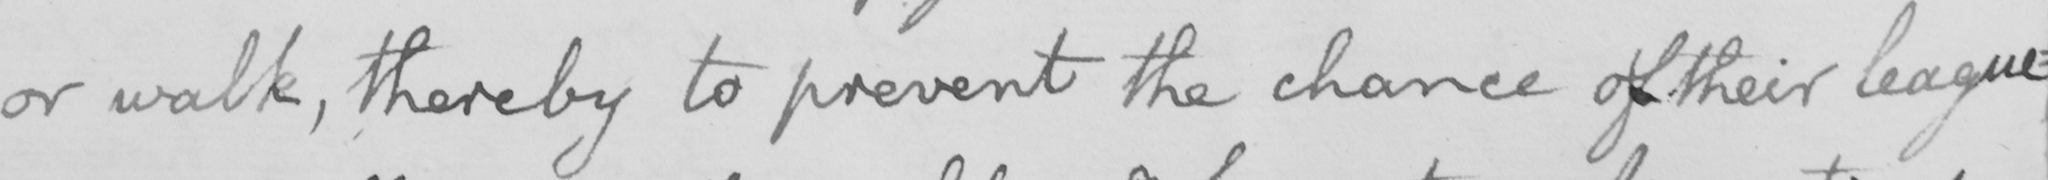What text is written in this handwritten line? or walk , thereby to prevent the chance of their league : 